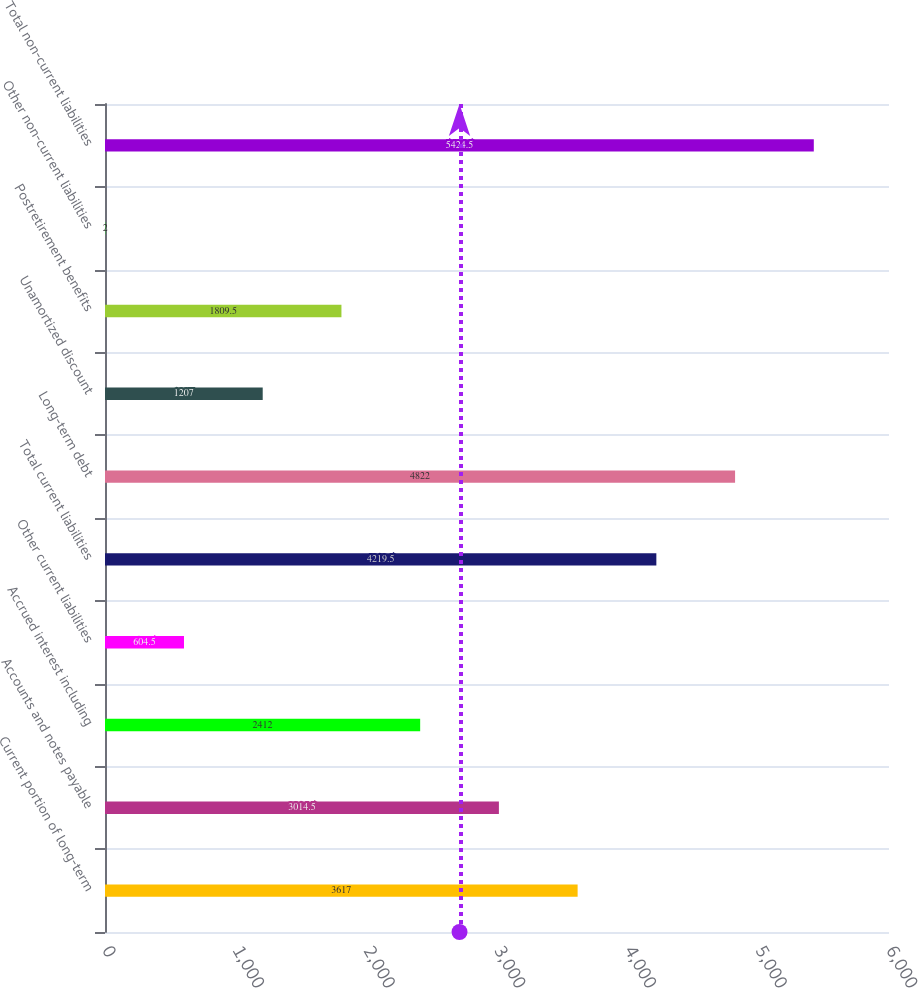Convert chart to OTSL. <chart><loc_0><loc_0><loc_500><loc_500><bar_chart><fcel>Current portion of long-term<fcel>Accounts and notes payable<fcel>Accrued interest including<fcel>Other current liabilities<fcel>Total current liabilities<fcel>Long-term debt<fcel>Unamortized discount<fcel>Postretirement benefits<fcel>Other non-current liabilities<fcel>Total non-current liabilities<nl><fcel>3617<fcel>3014.5<fcel>2412<fcel>604.5<fcel>4219.5<fcel>4822<fcel>1207<fcel>1809.5<fcel>2<fcel>5424.5<nl></chart> 